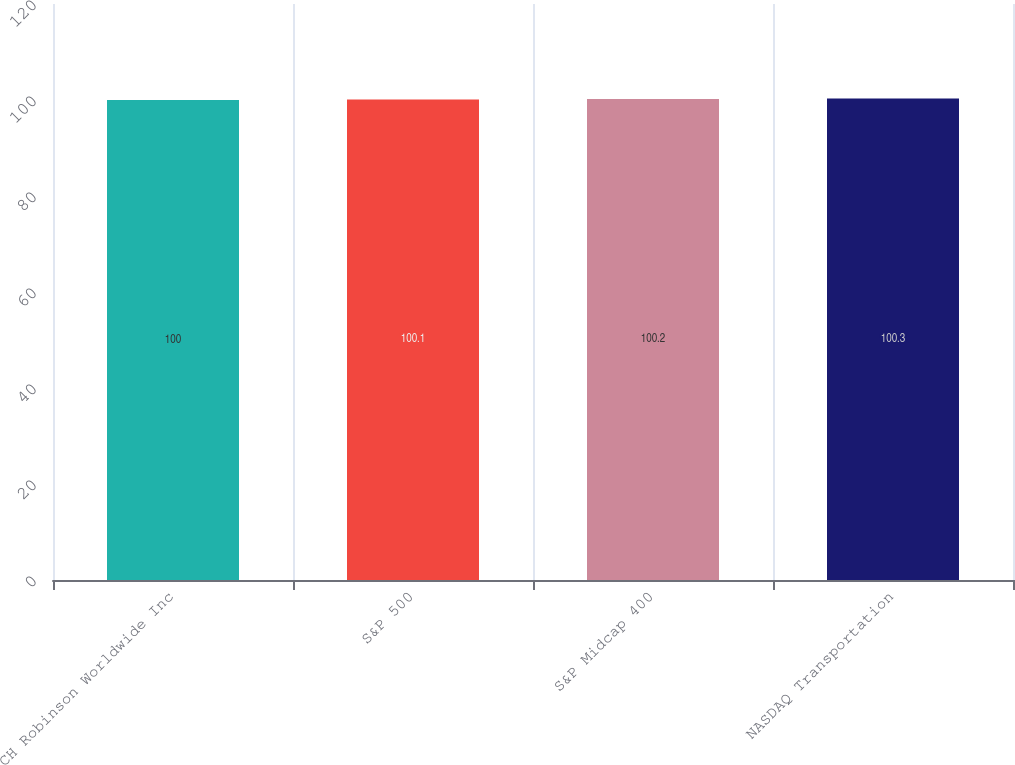Convert chart to OTSL. <chart><loc_0><loc_0><loc_500><loc_500><bar_chart><fcel>CH Robinson Worldwide Inc<fcel>S&P 500<fcel>S&P Midcap 400<fcel>NASDAQ Transportation<nl><fcel>100<fcel>100.1<fcel>100.2<fcel>100.3<nl></chart> 